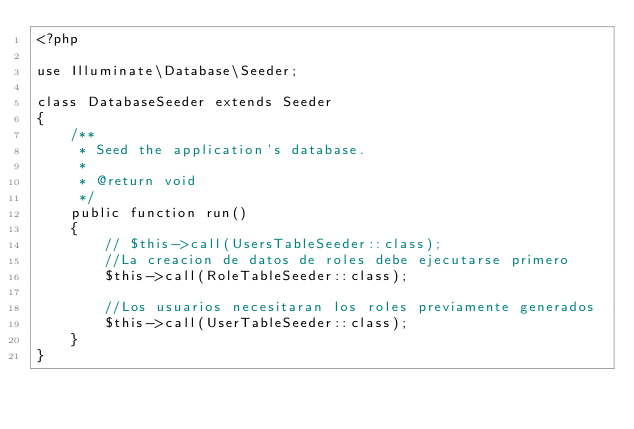Convert code to text. <code><loc_0><loc_0><loc_500><loc_500><_PHP_><?php

use Illuminate\Database\Seeder;

class DatabaseSeeder extends Seeder
{
    /**
     * Seed the application's database.
     *
     * @return void
     */
    public function run()
    {
        // $this->call(UsersTableSeeder::class);
        //La creacion de datos de roles debe ejecutarse primero
        $this->call(RoleTableSeeder::class);

        //Los usuarios necesitaran los roles previamente generados
        $this->call(UserTableSeeder::class);
    }
}
</code> 